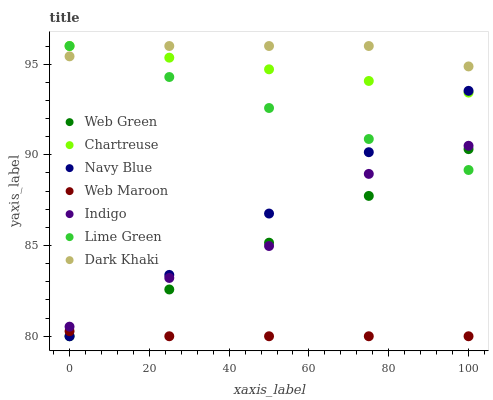Does Web Maroon have the minimum area under the curve?
Answer yes or no. Yes. Does Dark Khaki have the maximum area under the curve?
Answer yes or no. Yes. Does Navy Blue have the minimum area under the curve?
Answer yes or no. No. Does Navy Blue have the maximum area under the curve?
Answer yes or no. No. Is Web Green the smoothest?
Answer yes or no. Yes. Is Indigo the roughest?
Answer yes or no. Yes. Is Navy Blue the smoothest?
Answer yes or no. No. Is Navy Blue the roughest?
Answer yes or no. No. Does Navy Blue have the lowest value?
Answer yes or no. Yes. Does Dark Khaki have the lowest value?
Answer yes or no. No. Does Lime Green have the highest value?
Answer yes or no. Yes. Does Navy Blue have the highest value?
Answer yes or no. No. Is Indigo less than Chartreuse?
Answer yes or no. Yes. Is Lime Green greater than Web Maroon?
Answer yes or no. Yes. Does Dark Khaki intersect Lime Green?
Answer yes or no. Yes. Is Dark Khaki less than Lime Green?
Answer yes or no. No. Is Dark Khaki greater than Lime Green?
Answer yes or no. No. Does Indigo intersect Chartreuse?
Answer yes or no. No. 